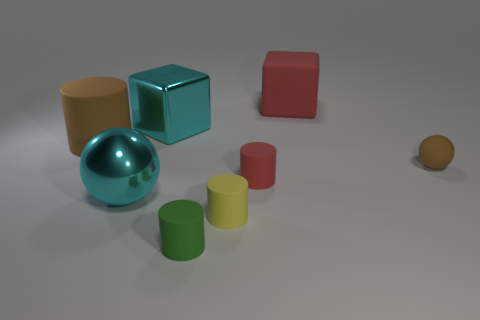Does the small ball have the same color as the big ball?
Offer a terse response. No. What shape is the big red thing that is made of the same material as the small yellow cylinder?
Your answer should be compact. Cube. There is a shiny thing in front of the large brown rubber cylinder; what size is it?
Your answer should be compact. Large. What shape is the tiny brown matte object?
Give a very brief answer. Sphere. There is a sphere in front of the brown rubber sphere; does it have the same size as the cube right of the small yellow cylinder?
Provide a short and direct response. Yes. What is the size of the brown matte object to the left of the matte object that is to the right of the big red object on the left side of the small brown thing?
Provide a succinct answer. Large. What shape is the brown matte object to the left of the ball to the right of the cyan thing that is to the right of the shiny ball?
Make the answer very short. Cylinder. The cyan metal thing behind the small brown object has what shape?
Your answer should be compact. Cube. Is the material of the yellow cylinder the same as the big block that is to the left of the green matte cylinder?
Give a very brief answer. No. How many other things are the same shape as the small brown object?
Offer a very short reply. 1. 